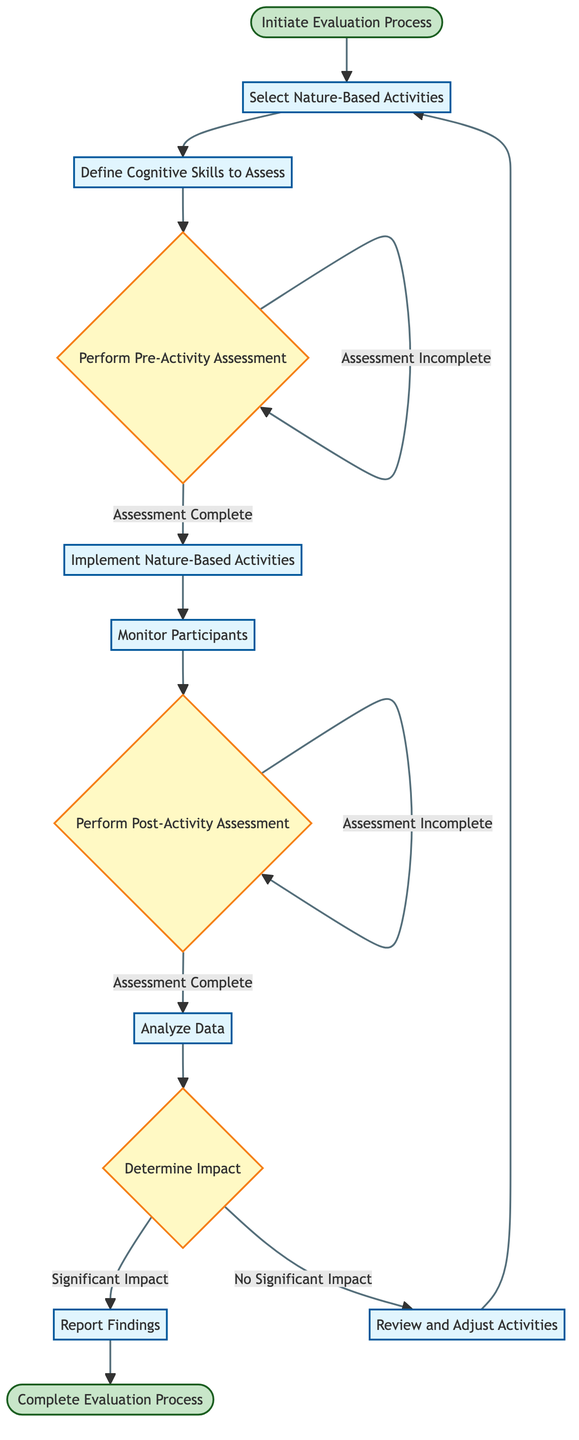What is the starting point of the evaluation process? The diagram shows that the evaluation process starts at the node labeled "Initiate Evaluation Process."
Answer: Initiate Evaluation Process What activities are selected in the process? According to the diagram, the selected activities are specific nature-based activities such as gardening, outdoor play, and nature walks.
Answer: Nature-Based Activities How many times can "Perform Pre-Activity Assessment" be repeated? The decision node for "Perform Pre-Activity Assessment" shows a loop where if the assessment is incomplete, it leads back to the same step. So it can be repeated indefinitely until the assessment completes.
Answer: Indefinitely What happens after "Analyze Data"? After "Analyze Data," the diagram continues to the decision node labeled "Determine Impact."
Answer: Determine Impact What is the condition to proceed from "Perform Post-Activity Assessment" to "Analyze Data"? The transition from "Perform Post-Activity Assessment" to "Analyze Data" occurs when the "Assessment Complete" condition is met.
Answer: Assessment Complete What leads to "Review and Adjust Activities"? If the condition "No Significant Impact" is determined at the "Determine Impact" node, the process leads to "Review and Adjust Activities."
Answer: No Significant Impact How many nodes are in the flowchart before reaching "Complete Evaluation Process"? The flowchart consists of 12 nodes before reaching the end node "Complete Evaluation Process."
Answer: Twelve What is the purpose of the "Monitor Participants" step? The purpose of "Monitor Participants" is to observe and document participant engagement and behavior during nature-based activities, as indicated in the diagram.
Answer: Document Engagement What is the outcome if "Assessment Incomplete" is determined in the pre-activity assessment? If "Assessment Incomplete" is determined, it leads back to "Perform Pre-Activity Assessment," indicating the assessment must be done again.
Answer: Perform Pre-Activity Assessment 